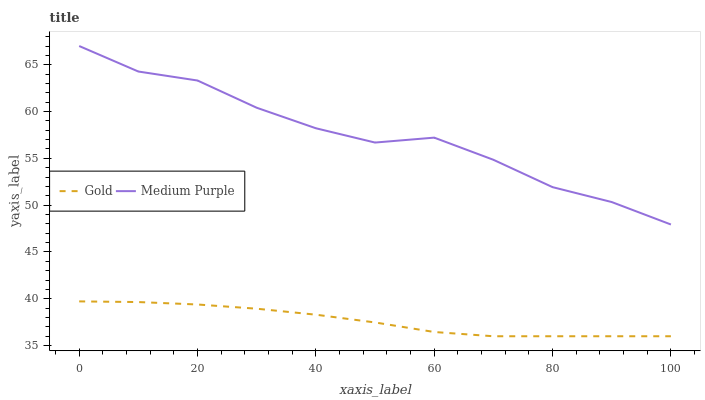Does Gold have the maximum area under the curve?
Answer yes or no. No. Is Gold the roughest?
Answer yes or no. No. Does Gold have the highest value?
Answer yes or no. No. Is Gold less than Medium Purple?
Answer yes or no. Yes. Is Medium Purple greater than Gold?
Answer yes or no. Yes. Does Gold intersect Medium Purple?
Answer yes or no. No. 